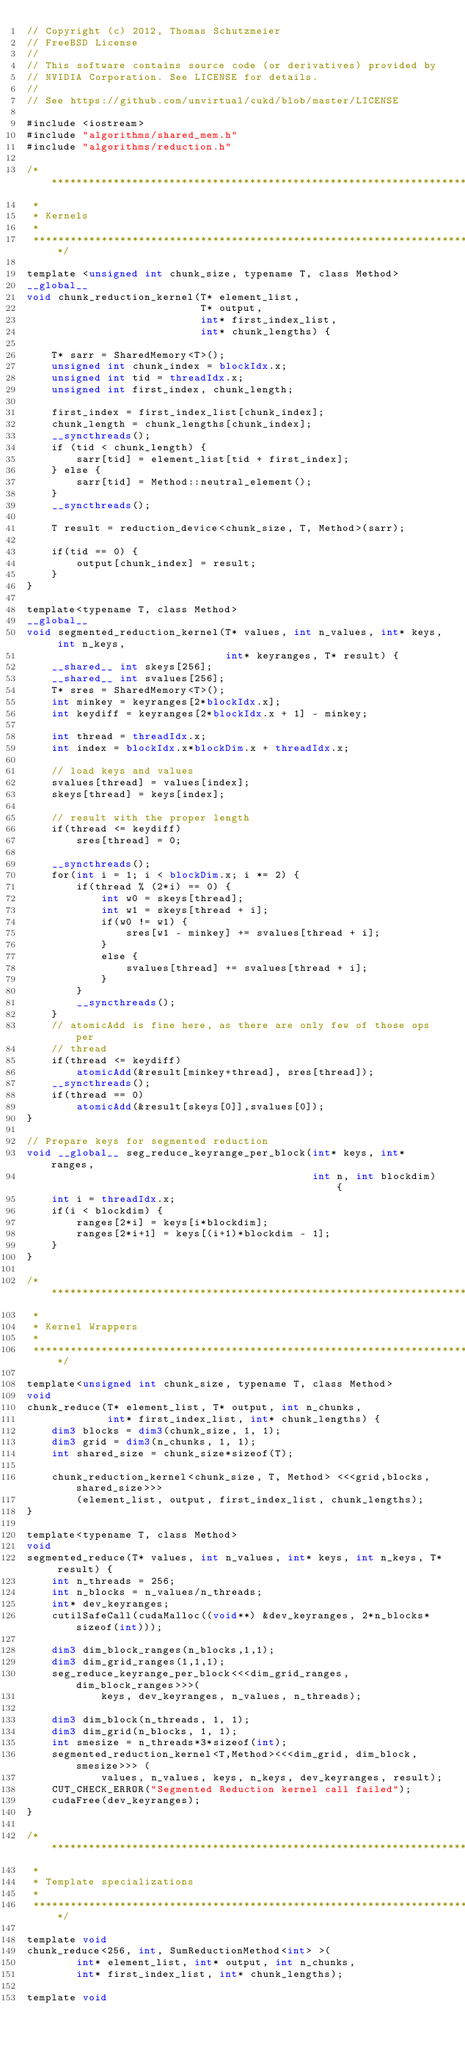<code> <loc_0><loc_0><loc_500><loc_500><_Cuda_>// Copyright (c) 2012, Thomas Schutzmeier
// FreeBSD License
//
// This software contains source code (or derivatives) provided by
// NVIDIA Corporation. See LICENSE for details.
//
// See https://github.com/unvirtual/cukd/blob/master/LICENSE

#include <iostream>
#include "algorithms/shared_mem.h"
#include "algorithms/reduction.h"

/**********************************************************************************
 *
 * Kernels
 *
 **********************************************************************************/

template <unsigned int chunk_size, typename T, class Method>
__global__
void chunk_reduction_kernel(T* element_list,
                            T* output,
                            int* first_index_list,
                            int* chunk_lengths) {

    T* sarr = SharedMemory<T>();
    unsigned int chunk_index = blockIdx.x;
    unsigned int tid = threadIdx.x;
    unsigned int first_index, chunk_length;

    first_index = first_index_list[chunk_index];
    chunk_length = chunk_lengths[chunk_index];
    __syncthreads();
    if (tid < chunk_length) {
        sarr[tid] = element_list[tid + first_index];
    } else {
        sarr[tid] = Method::neutral_element();
    }
    __syncthreads();

    T result = reduction_device<chunk_size, T, Method>(sarr);

    if(tid == 0) {
        output[chunk_index] = result;
    }
}

template<typename T, class Method>
__global__
void segmented_reduction_kernel(T* values, int n_values, int* keys, int n_keys,
                                int* keyranges, T* result) {
    __shared__ int skeys[256];
    __shared__ int svalues[256];
    T* sres = SharedMemory<T>();
    int minkey = keyranges[2*blockIdx.x];
    int keydiff = keyranges[2*blockIdx.x + 1] - minkey;

    int thread = threadIdx.x;
    int index = blockIdx.x*blockDim.x + threadIdx.x;

    // load keys and values
    svalues[thread] = values[index];
    skeys[thread] = keys[index];

    // result with the proper length
    if(thread <= keydiff)
        sres[thread] = 0;

    __syncthreads();
    for(int i = 1; i < blockDim.x; i *= 2) {
        if(thread % (2*i) == 0) {
            int w0 = skeys[thread];
            int w1 = skeys[thread + i];
            if(w0 != w1) {
                sres[w1 - minkey] += svalues[thread + i];
            }
            else {
                svalues[thread] += svalues[thread + i];
            }
        }
        __syncthreads();
    }
    // atomicAdd is fine here, as there are only few of those ops per
    // thread
    if(thread <= keydiff)
        atomicAdd(&result[minkey+thread], sres[thread]);
    __syncthreads();
    if(thread == 0)
        atomicAdd(&result[skeys[0]],svalues[0]);
}

// Prepare keys for segmented reduction
void __global__ seg_reduce_keyrange_per_block(int* keys, int* ranges,
                                              int n, int blockdim) {
    int i = threadIdx.x;
    if(i < blockdim) {
        ranges[2*i] = keys[i*blockdim];
        ranges[2*i+1] = keys[(i+1)*blockdim - 1];
    }
}

/**********************************************************************************
 *
 * Kernel Wrappers
 *
 **********************************************************************************/

template<unsigned int chunk_size, typename T, class Method>
void
chunk_reduce(T* element_list, T* output, int n_chunks,
             int* first_index_list, int* chunk_lengths) {
    dim3 blocks = dim3(chunk_size, 1, 1);
    dim3 grid = dim3(n_chunks, 1, 1);
    int shared_size = chunk_size*sizeof(T);

    chunk_reduction_kernel<chunk_size, T, Method> <<<grid,blocks,shared_size>>>
        (element_list, output, first_index_list, chunk_lengths);
}

template<typename T, class Method>
void
segmented_reduce(T* values, int n_values, int* keys, int n_keys, T* result) {
    int n_threads = 256;
    int n_blocks = n_values/n_threads;
    int* dev_keyranges;
    cutilSafeCall(cudaMalloc((void**) &dev_keyranges, 2*n_blocks*sizeof(int)));

    dim3 dim_block_ranges(n_blocks,1,1);
    dim3 dim_grid_ranges(1,1,1);
    seg_reduce_keyrange_per_block<<<dim_grid_ranges, dim_block_ranges>>>(
            keys, dev_keyranges, n_values, n_threads);

    dim3 dim_block(n_threads, 1, 1);
    dim3 dim_grid(n_blocks, 1, 1);
    int smesize = n_threads*3*sizeof(int);
    segmented_reduction_kernel<T,Method><<<dim_grid, dim_block,smesize>>> (
            values, n_values, keys, n_keys, dev_keyranges, result);
    CUT_CHECK_ERROR("Segmented Reduction kernel call failed");
    cudaFree(dev_keyranges);
}

/**********************************************************************************
 *
 * Template specializations
 *
 **********************************************************************************/

template void
chunk_reduce<256, int, SumReductionMethod<int> >(
        int* element_list, int* output, int n_chunks,
        int* first_index_list, int* chunk_lengths);

template void</code> 